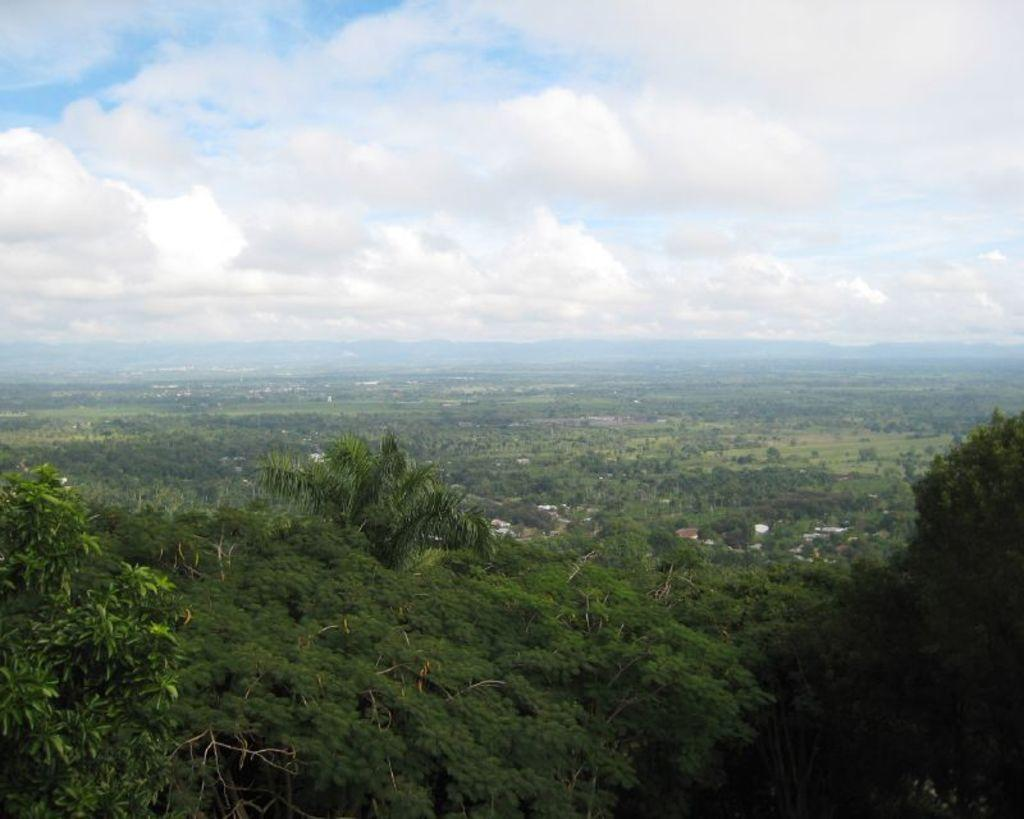What type of location is shown in the image? The image depicts a city. What structures can be seen in the city? There are buildings in the image. Are there any natural elements present in the city? Yes, there are trees in the image. What is visible at the top of the image? The sky is visible at the top of the image. What can be seen in the sky? There are clouds in the sky. What type of landscape is visible in the background of the image? There are mountains visible in the background of the image. How often do the waves crash against the shore in the image? There is no shore or ocean present in the image, so there are no waves to crash. 